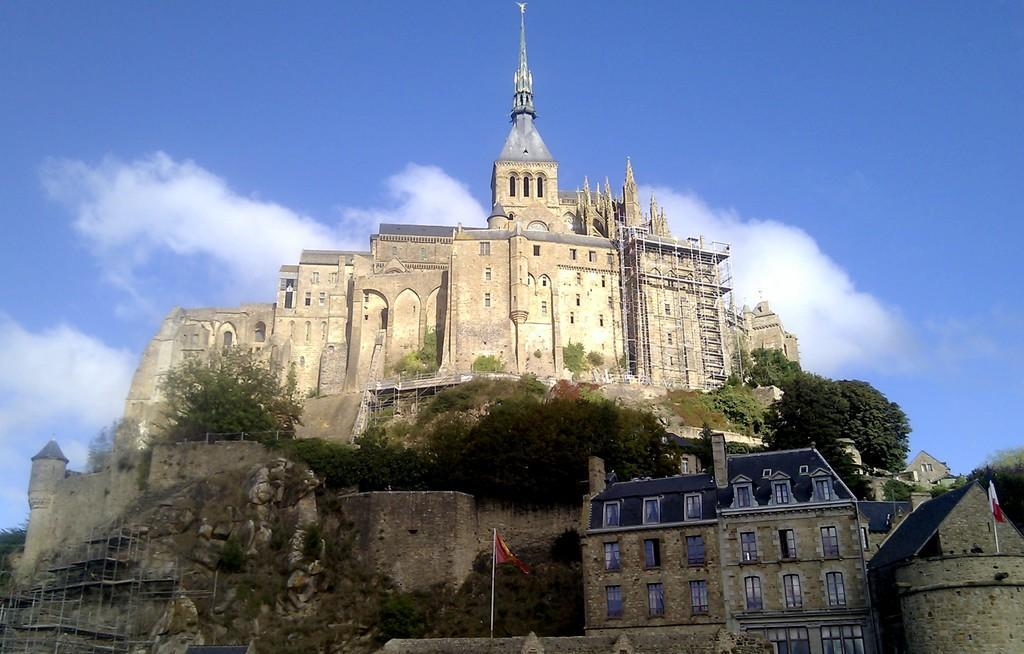Can you describe this image briefly? In this image we can see few buildings, trees, flags and the sky with clouds in the background. 